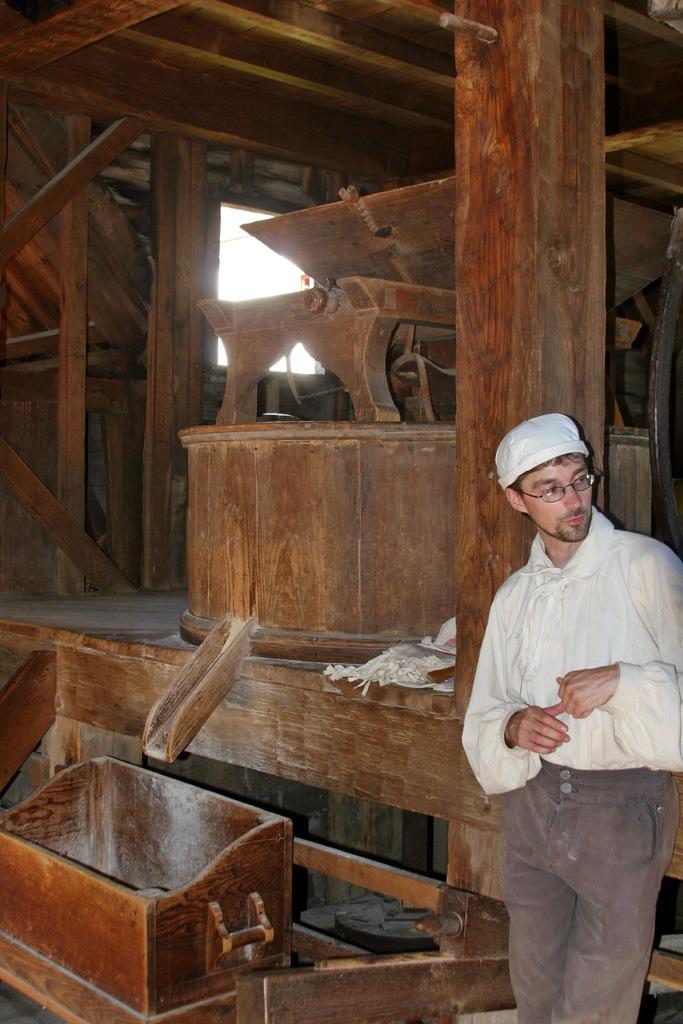What can be seen on the right side of the image? There is a person on the right side of the image. Can you describe the person's appearance? The person is wearing a white cap and glasses. What is visible in the background of the image? There are woods visible in the background of the image. What type of fruit is hanging from the trees in the image? There are no trees or fruit present in the image; it features a person wearing a white cap and glasses with woods visible in the background. 